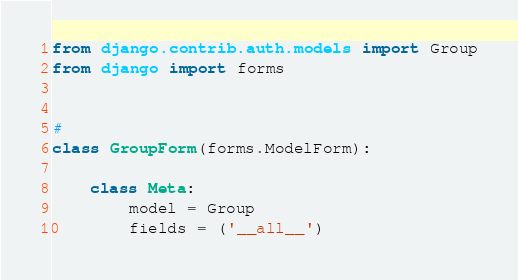Convert code to text. <code><loc_0><loc_0><loc_500><loc_500><_Python_>from django.contrib.auth.models import Group
from django import forms


#
class GroupForm(forms.ModelForm):

    class Meta:
        model = Group
        fields = ('__all__')
</code> 